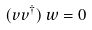Convert formula to latex. <formula><loc_0><loc_0><loc_500><loc_500>( v v ^ { \dagger } ) \, w = 0</formula> 